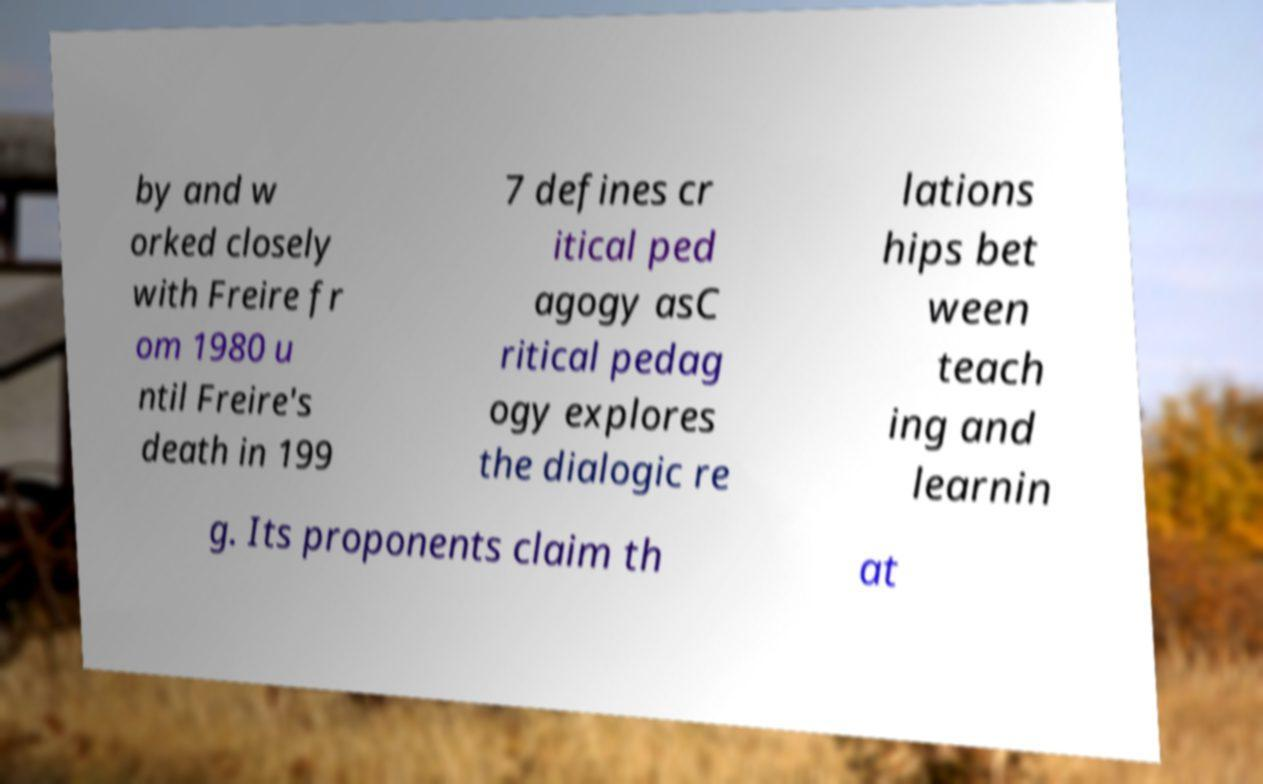Please read and relay the text visible in this image. What does it say? by and w orked closely with Freire fr om 1980 u ntil Freire's death in 199 7 defines cr itical ped agogy asC ritical pedag ogy explores the dialogic re lations hips bet ween teach ing and learnin g. Its proponents claim th at 